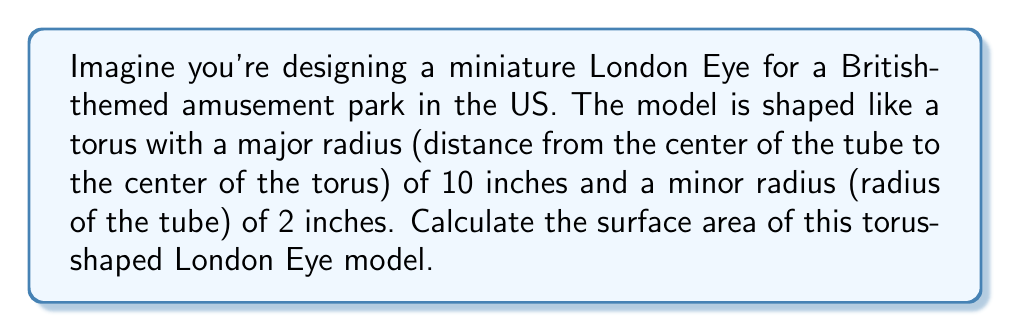Show me your answer to this math problem. To calculate the surface area of a torus, we'll use the formula:

$$A = 4\pi^2Rr$$

Where:
$A$ = surface area
$R$ = major radius (distance from the center of the tube to the center of the torus)
$r$ = minor radius (radius of the tube)

Given:
$R = 10$ inches
$r = 2$ inches

Let's substitute these values into our formula:

$$\begin{align*}
A &= 4\pi^2Rr \\
&= 4\pi^2 \cdot 10 \cdot 2 \\
&= 80\pi^2
\end{align*}$$

Now, let's calculate this value:

$$\begin{align*}
A &= 80\pi^2 \\
&\approx 80 \cdot 9.8696 \\
&\approx 789.57 \text{ square inches}
\end{align*}$$

[asy]
import geometry;

real R = 10;
real r = 2;
pair O = (0,0);

path p = circle(O, R);
path q = circle((R,0), r);

draw(p, dashed);
draw(q);
draw((R-r,0)--(R+r,0));
draw(O--(R,0));

label("R", (R/2,0), S);
label("r", (R,r/2), E);

draw(scale(0.7)*shift(-15,0)*p, dashed);
draw(scale(0.7)*shift(-15,0)*rotate(90)*q);

[/asy]

This diagram illustrates the torus shape, with $R$ representing the major radius and $r$ representing the minor radius.
Answer: The surface area of the torus-shaped London Eye model is approximately 789.57 square inches. 